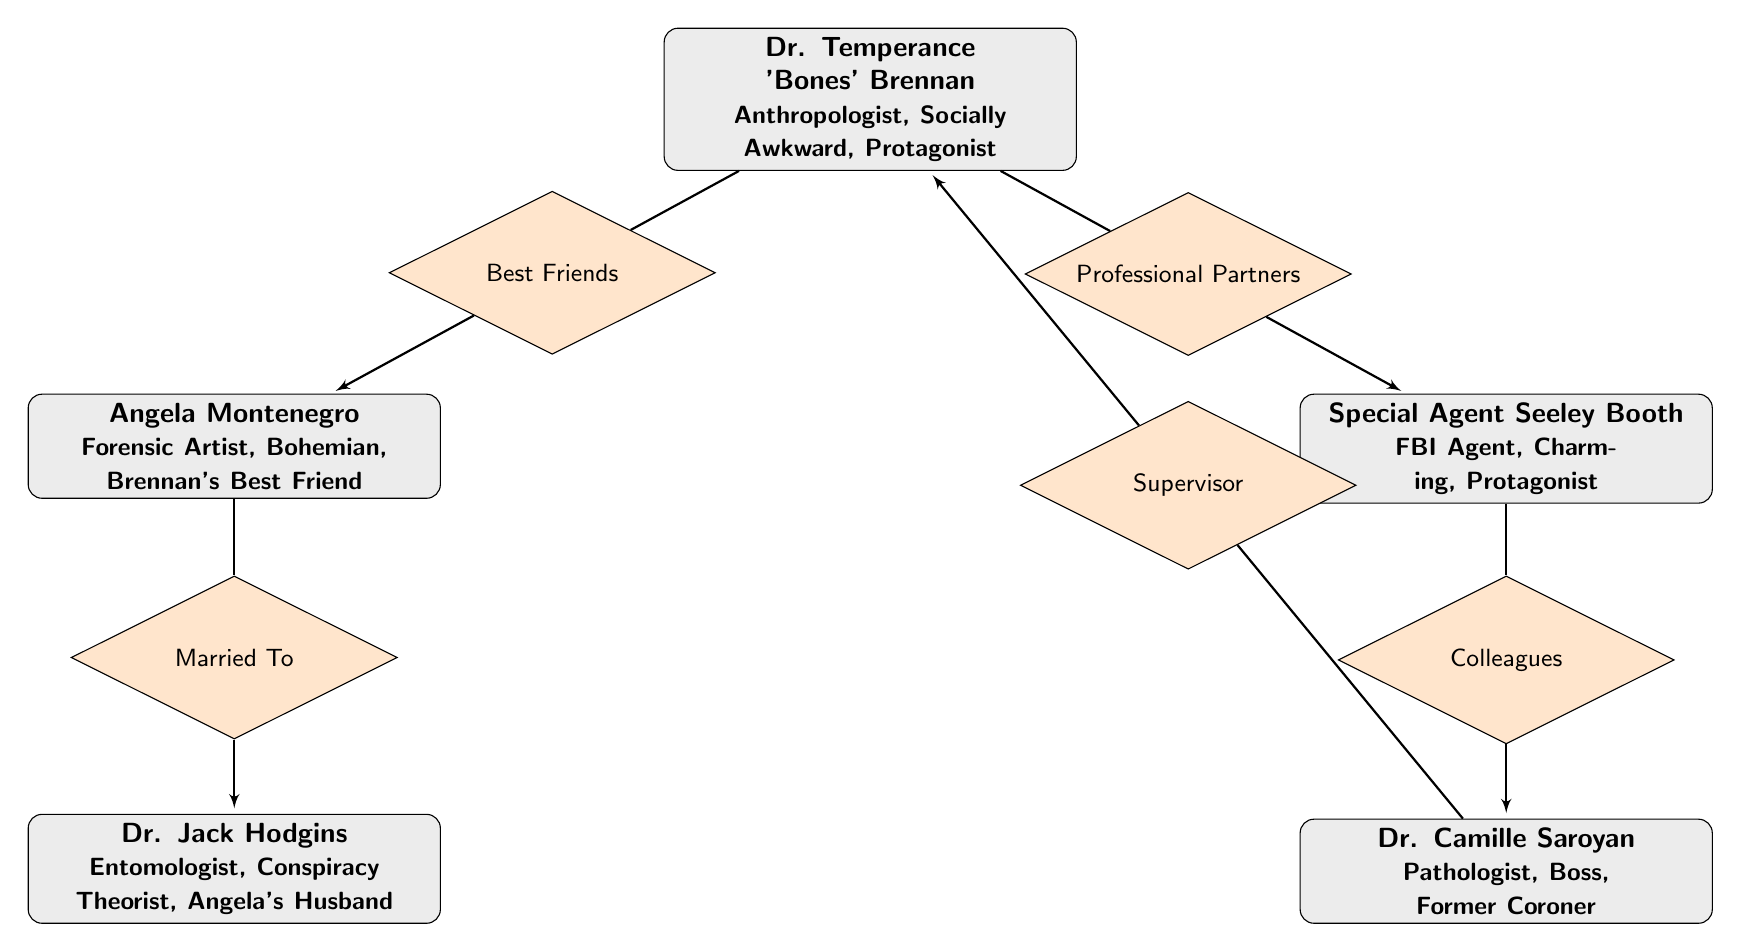What is Dr. Temperance 'Bones' Brennan's occupation? The diagram shows that Dr. Temperance 'Bones' Brennan is an “Anthropologist” under her attributes.
Answer: Anthropologist Who is Angela Montenegro married to? According to the diagram, Angela Montenegro has a relationship labeled “Married To” Dr. Jack Hodgins.
Answer: Dr. Jack Hodgins What role does Dr. Camille Saroyan have in relation to Dr. Temperance 'Bones' Brennan? The diagram indicates that Dr. Camille Saroyan is the “Supervisor” of Dr. Temperance 'Bones' Brennan, showing a professional relationship.
Answer: Supervisor How many characters are involved in the diagram? There are 5 entities (characters) represented in the diagram.
Answer: 5 What type of relationship exists between Special Agent Seeley Booth and Dr. Camille Saroyan? The relationship labeled on the diagram between Special Agent Seeley Booth and Dr. Camille Saroyan is classified as “Colleagues”.
Answer: Colleagues Who is Brennan's best friend? In the diagram, it specifies that Angela Montenegro is the “Best Friend” of Dr. Temperance 'Bones' Brennan.
Answer: Angela Montenegro Which character is listed as an Entomologist? The diagram shows that Dr. Jack Hodgins is identified as an “Entomologist” under his attributes.
Answer: Dr. Jack Hodgins What kind of relationship exists between Angela Montenegro and Dr. Jack Hodgins? The diagram illustrates that Angela Montenegro has a romantic relationship designated as “Married To” with Dr. Jack Hodgins.
Answer: Married To What color represents the relationships in the diagram? Here, the relationships are filled in orange, which can be perceived by looking at the diamonds connecting the character nodes.
Answer: Orange 